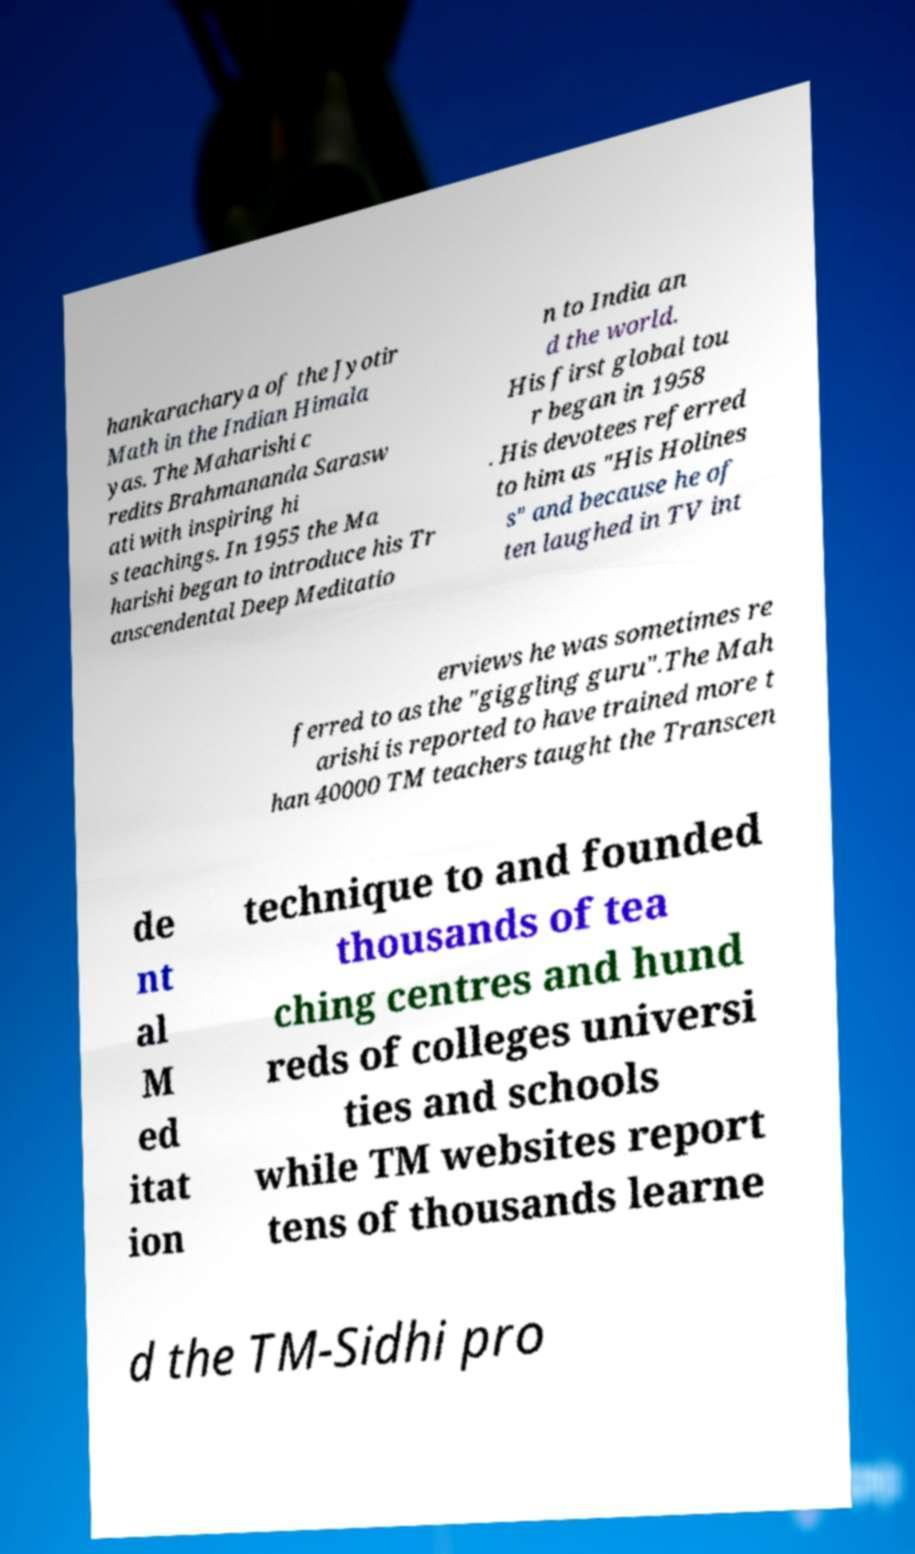Could you extract and type out the text from this image? hankaracharya of the Jyotir Math in the Indian Himala yas. The Maharishi c redits Brahmananda Sarasw ati with inspiring hi s teachings. In 1955 the Ma harishi began to introduce his Tr anscendental Deep Meditatio n to India an d the world. His first global tou r began in 1958 . His devotees referred to him as "His Holines s" and because he of ten laughed in TV int erviews he was sometimes re ferred to as the "giggling guru".The Mah arishi is reported to have trained more t han 40000 TM teachers taught the Transcen de nt al M ed itat ion technique to and founded thousands of tea ching centres and hund reds of colleges universi ties and schools while TM websites report tens of thousands learne d the TM-Sidhi pro 